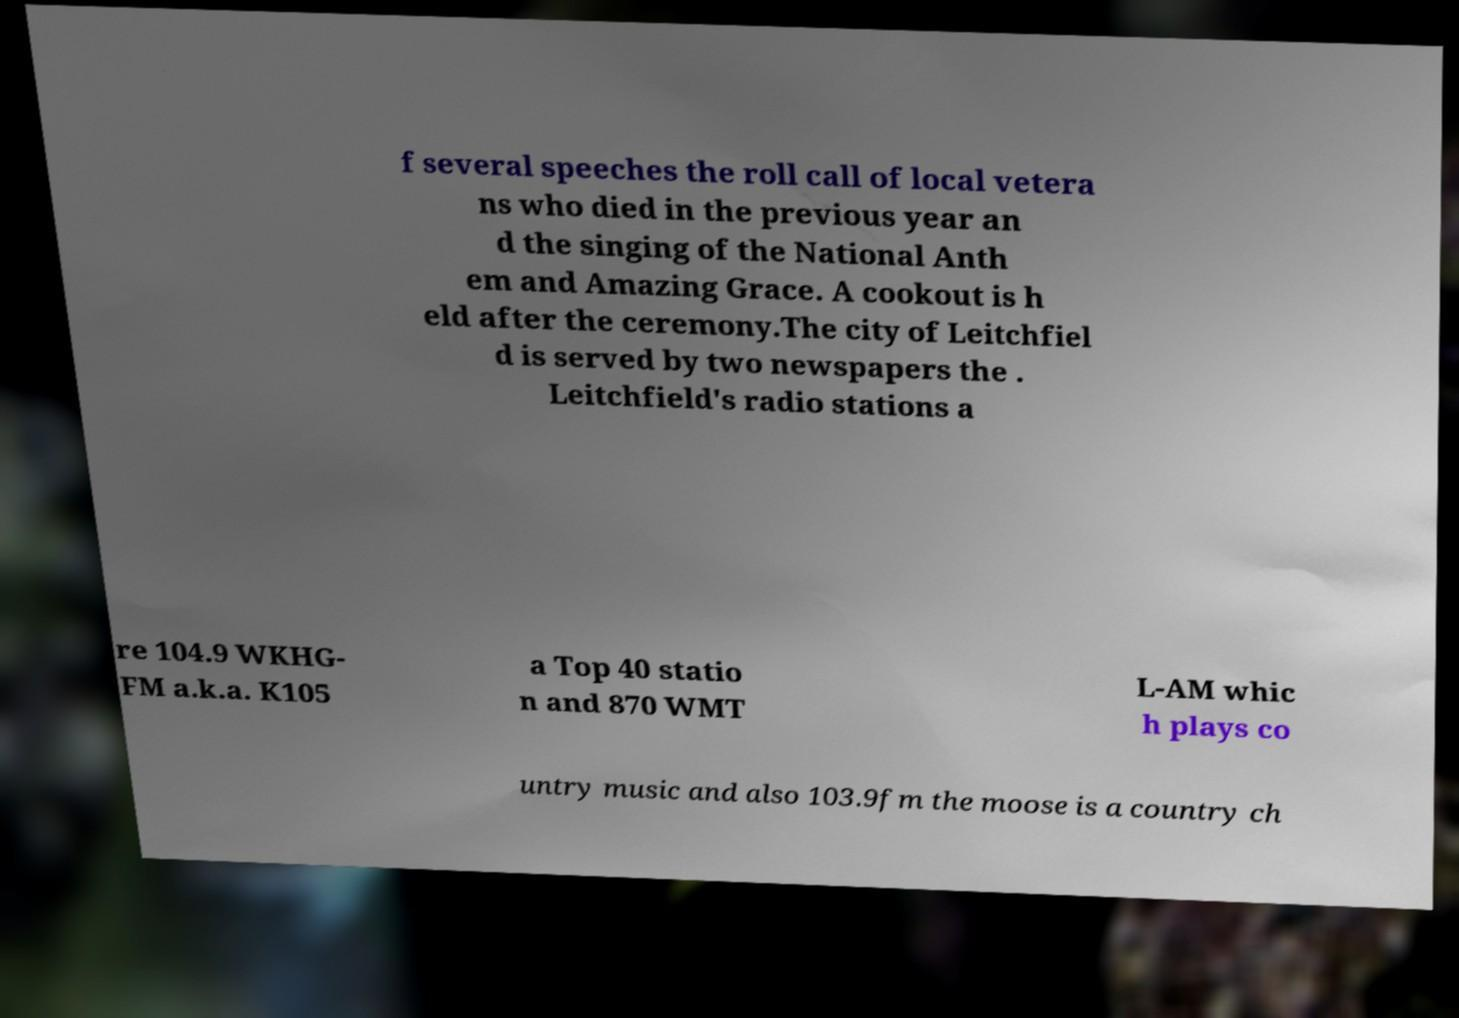Can you read and provide the text displayed in the image?This photo seems to have some interesting text. Can you extract and type it out for me? f several speeches the roll call of local vetera ns who died in the previous year an d the singing of the National Anth em and Amazing Grace. A cookout is h eld after the ceremony.The city of Leitchfiel d is served by two newspapers the . Leitchfield's radio stations a re 104.9 WKHG- FM a.k.a. K105 a Top 40 statio n and 870 WMT L-AM whic h plays co untry music and also 103.9fm the moose is a country ch 